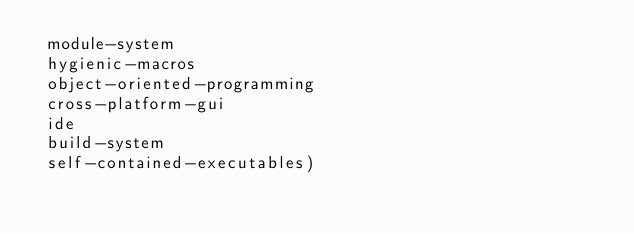Convert code to text. <code><loc_0><loc_0><loc_500><loc_500><_Scheme_> module-system
 hygienic-macros
 object-oriented-programming
 cross-platform-gui
 ide
 build-system
 self-contained-executables)
</code> 